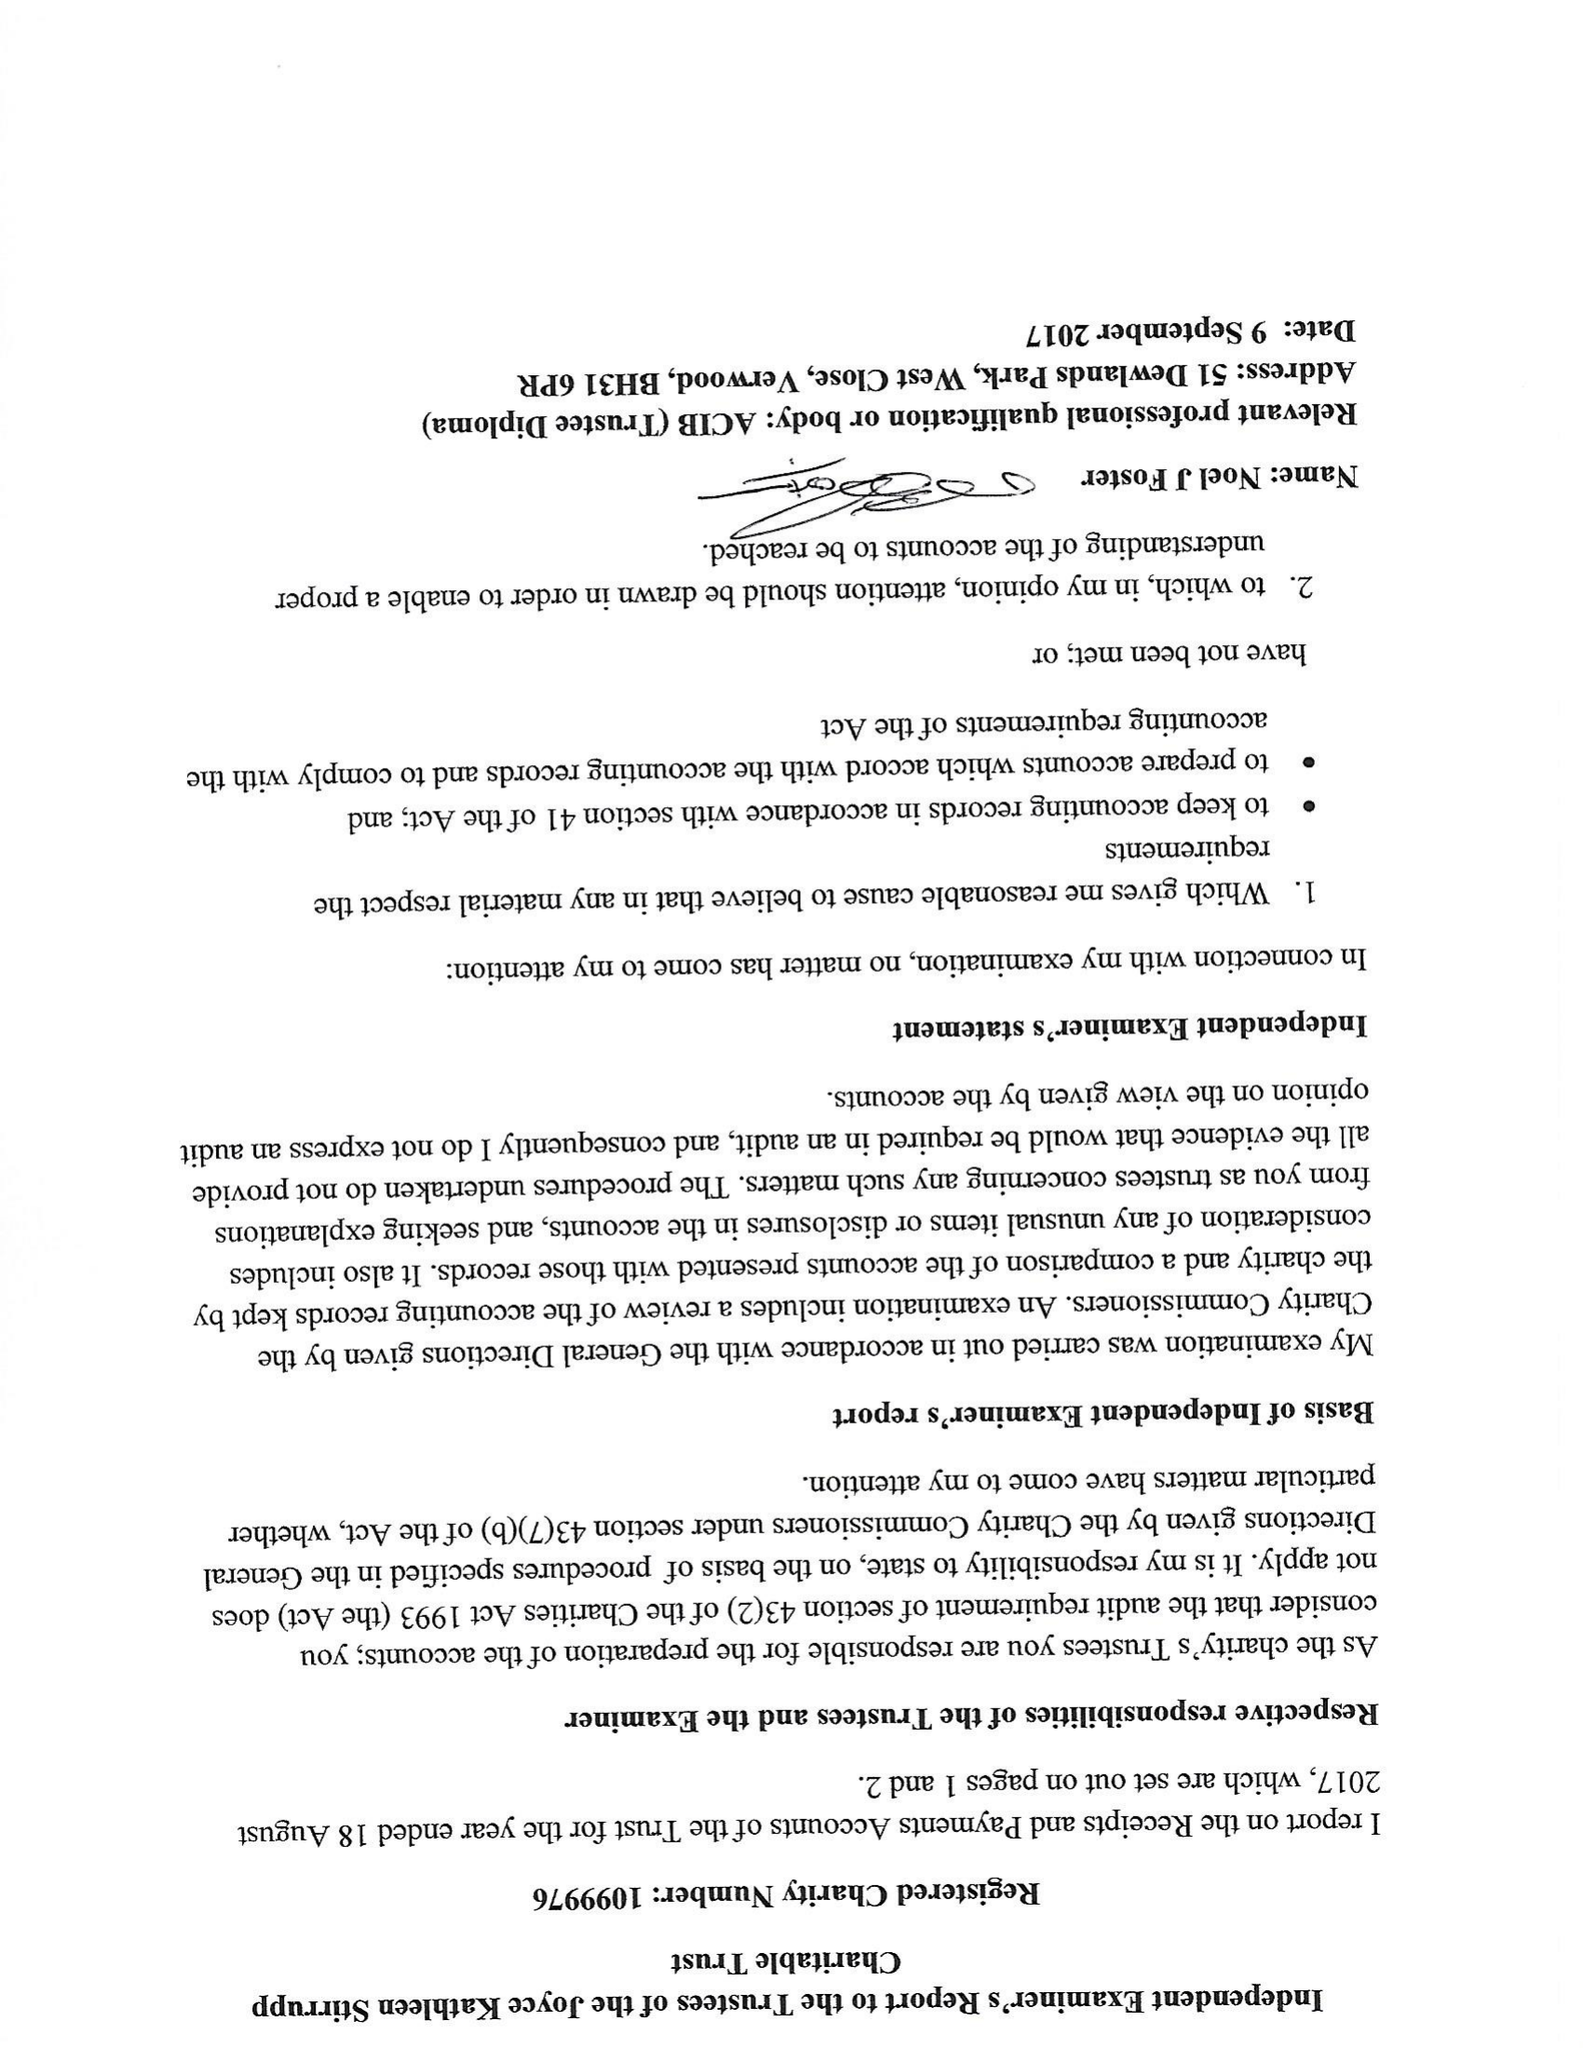What is the value for the report_date?
Answer the question using a single word or phrase. 2017-08-18 